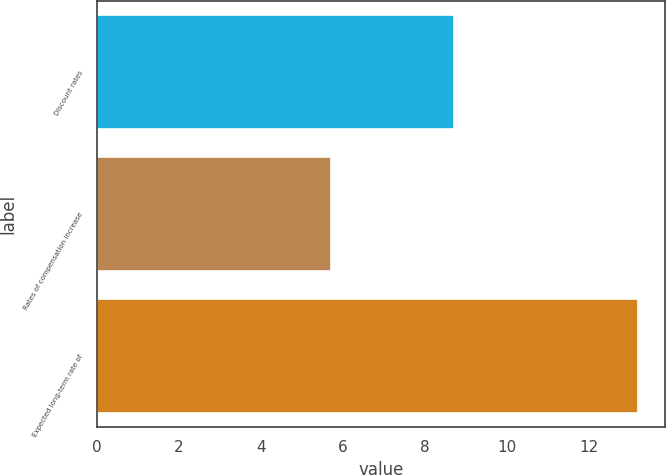Convert chart to OTSL. <chart><loc_0><loc_0><loc_500><loc_500><bar_chart><fcel>Discount rates<fcel>Rates of compensation increase<fcel>Expected long-term rate of<nl><fcel>8.7<fcel>5.7<fcel>13.2<nl></chart> 